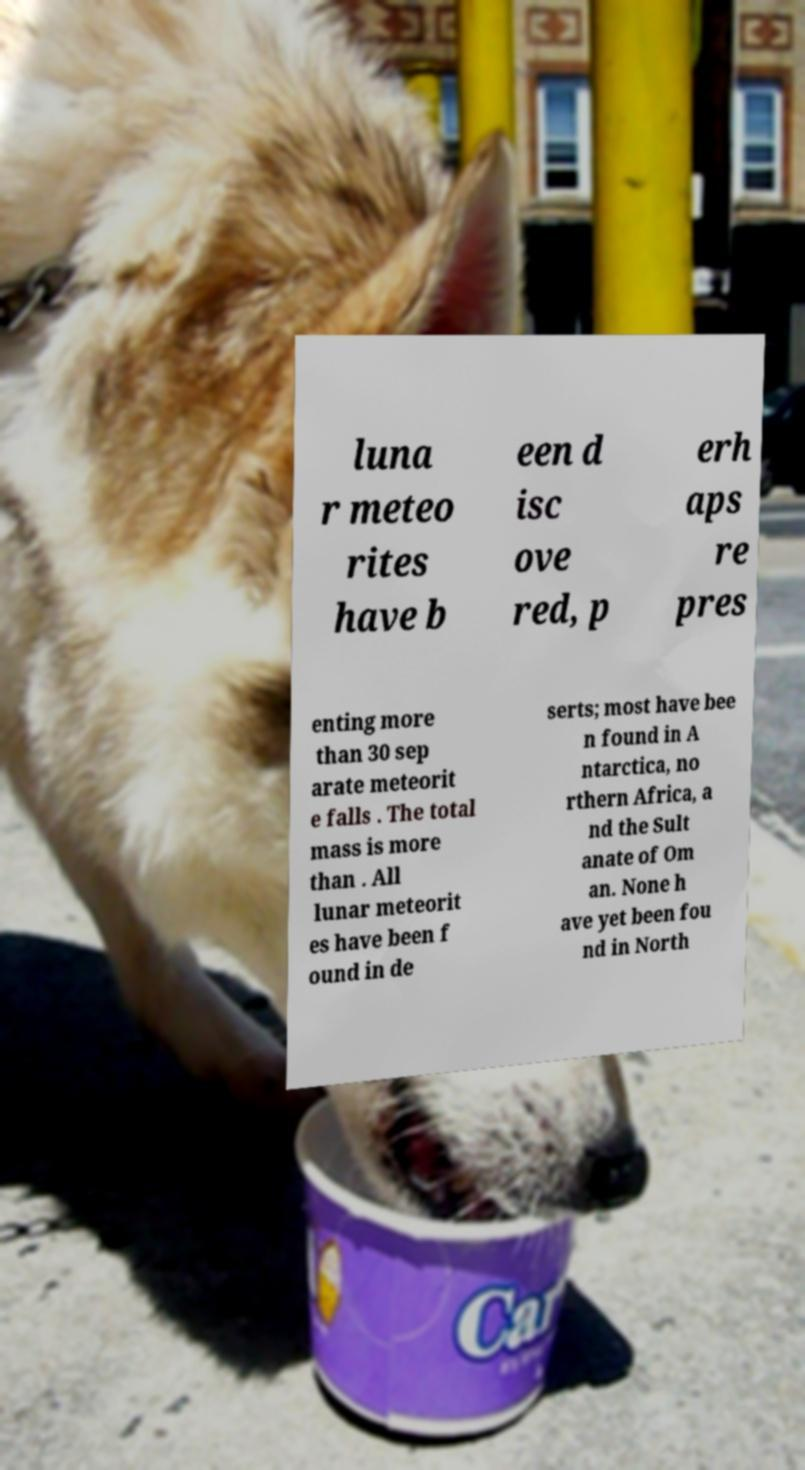Please read and relay the text visible in this image. What does it say? luna r meteo rites have b een d isc ove red, p erh aps re pres enting more than 30 sep arate meteorit e falls . The total mass is more than . All lunar meteorit es have been f ound in de serts; most have bee n found in A ntarctica, no rthern Africa, a nd the Sult anate of Om an. None h ave yet been fou nd in North 